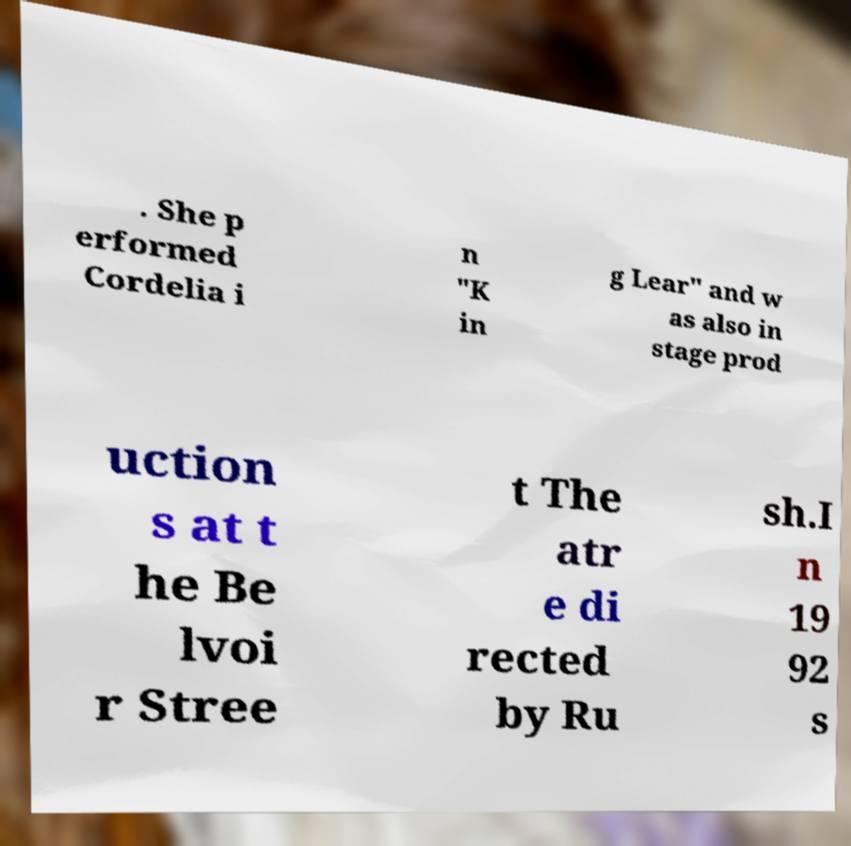I need the written content from this picture converted into text. Can you do that? . She p erformed Cordelia i n "K in g Lear" and w as also in stage prod uction s at t he Be lvoi r Stree t The atr e di rected by Ru sh.I n 19 92 s 